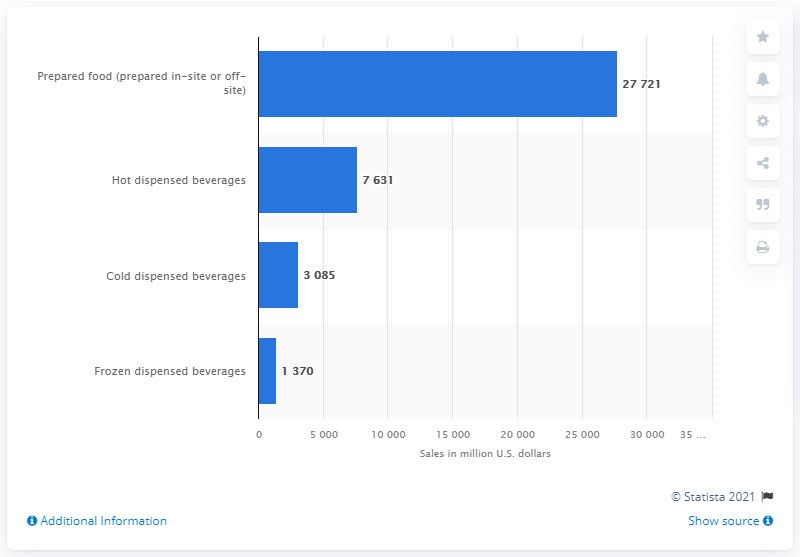Draw attention to some important aspects in this diagram. In 2019, hot dispensed beverages generated $7,631 million in sales for the U.S. convenience store industry. 